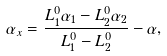Convert formula to latex. <formula><loc_0><loc_0><loc_500><loc_500>\alpha _ { x } = \frac { L _ { 1 } ^ { 0 } \alpha _ { 1 } - L _ { 2 } ^ { 0 } \alpha _ { 2 } } { L _ { 1 } ^ { 0 } - L _ { 2 } ^ { 0 } } - \alpha ,</formula> 